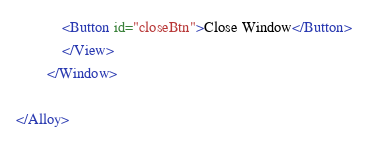<code> <loc_0><loc_0><loc_500><loc_500><_XML_>			<Button id="closeBtn">Close Window</Button>
			</View>
		</Window>
		
</Alloy>

</code> 